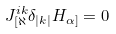Convert formula to latex. <formula><loc_0><loc_0><loc_500><loc_500>J ^ { i k } _ { [ \aleph } \delta _ { | k | } H _ { \alpha ] } = 0</formula> 